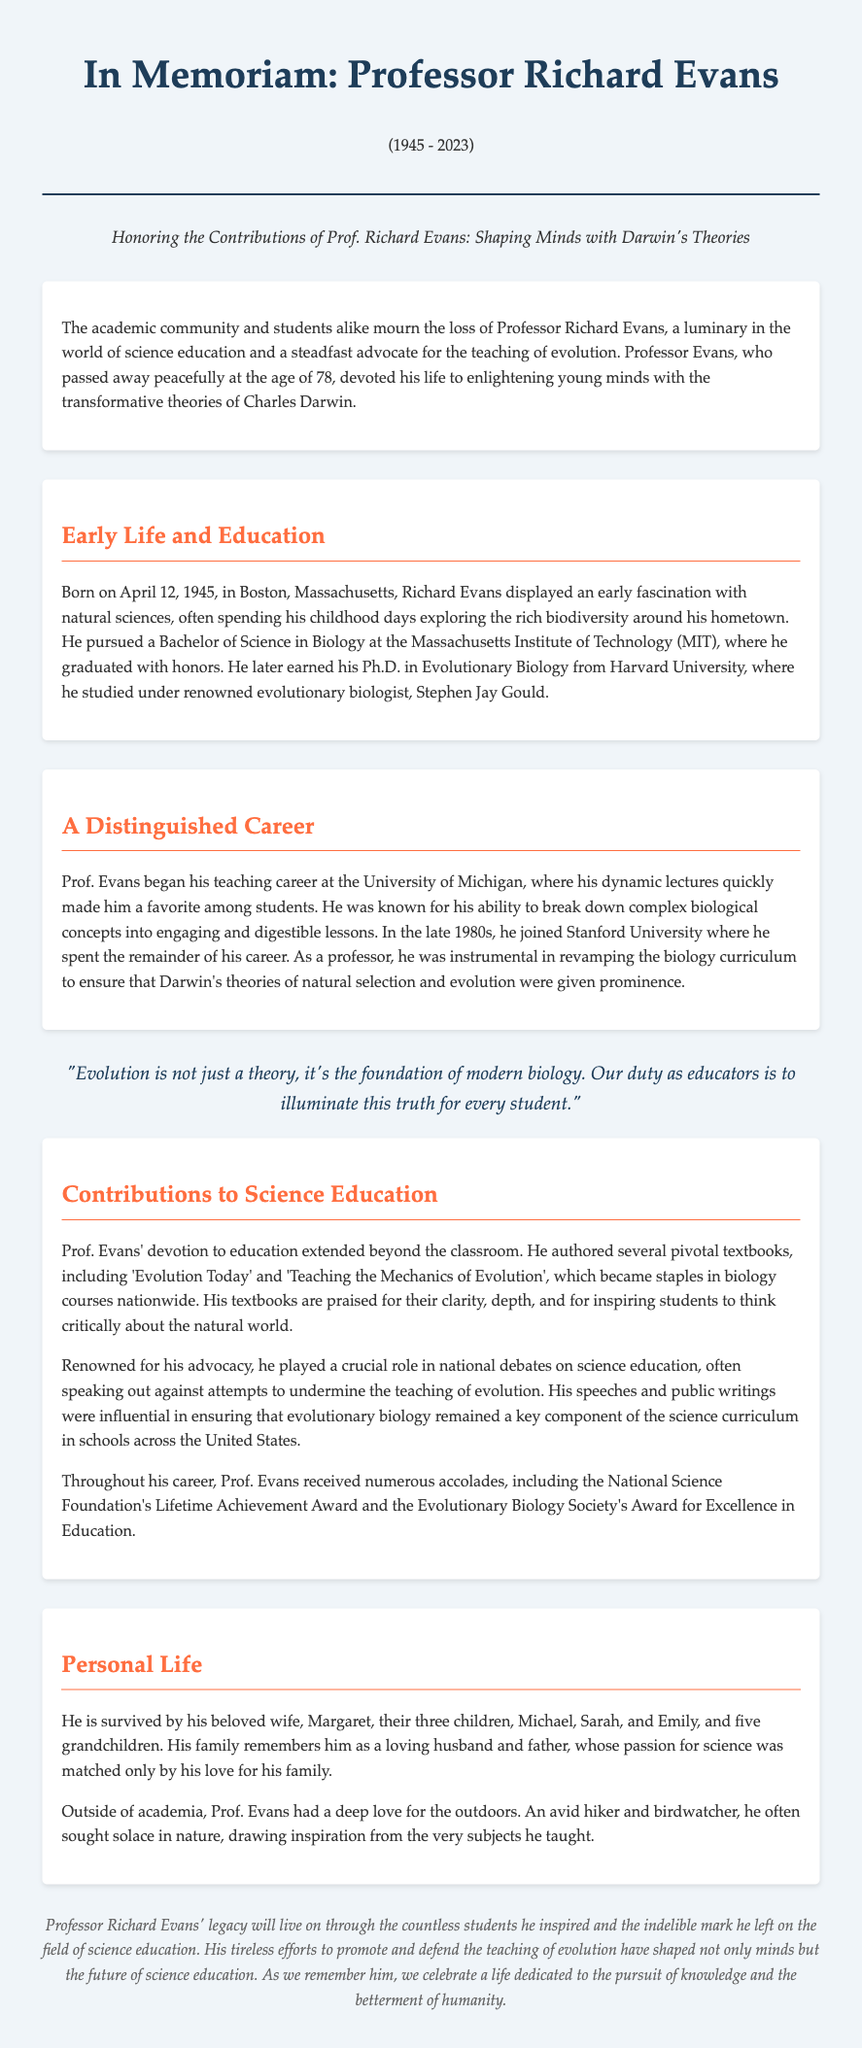what was the age of Professor Richard Evans at the time of death? The document states that Professor Evans passed away at the age of 78.
Answer: 78 when was Professor Richard Evans born? According to the obituary, Professor Evans was born on April 12, 1945.
Answer: April 12, 1945 which university did he join in the late 1980s? The document mentions that Professor Evans joined Stanford University in the late 1980s.
Answer: Stanford University what is the title of one of the pivotal textbooks authored by Prof. Evans? The obituary lists 'Evolution Today' as one of the pivotal textbooks authored by Prof. Evans.
Answer: Evolution Today who survived Professor Richard Evans? The document states that he is survived by his wife Margaret, three children, and five grandchildren.
Answer: Margaret, three children, five grandchildren what was the foundation of his teaching philosophy? Professor Evans believed that "Evolution is not just a theory, it's the foundation of modern biology."
Answer: foundation of modern biology what award did Prof. Evans receive for his educational contributions? The document lists the National Science Foundation's Lifetime Achievement Award as one of the accolades he received.
Answer: National Science Foundation's Lifetime Achievement Award which naturalist influenced Professor Evans’ studies during his Ph.D.? The obituary states that he studied under Stephen Jay Gould at Harvard University.
Answer: Stephen Jay Gould 